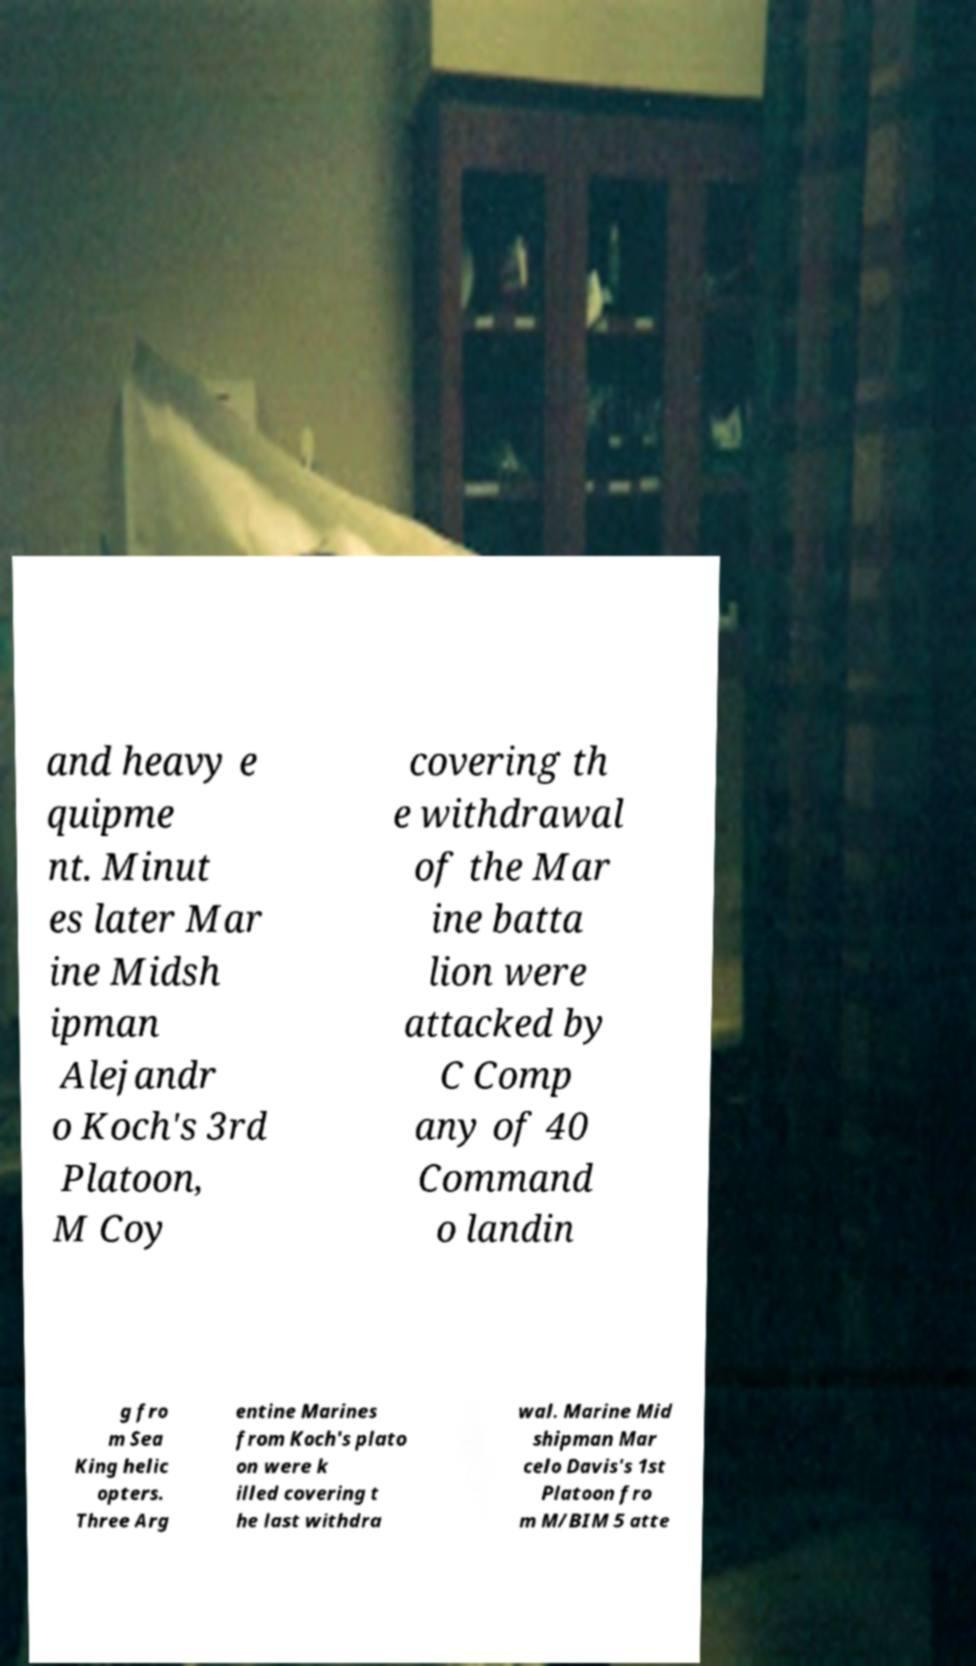Could you extract and type out the text from this image? and heavy e quipme nt. Minut es later Mar ine Midsh ipman Alejandr o Koch's 3rd Platoon, M Coy covering th e withdrawal of the Mar ine batta lion were attacked by C Comp any of 40 Command o landin g fro m Sea King helic opters. Three Arg entine Marines from Koch's plato on were k illed covering t he last withdra wal. Marine Mid shipman Mar celo Davis's 1st Platoon fro m M/BIM 5 atte 